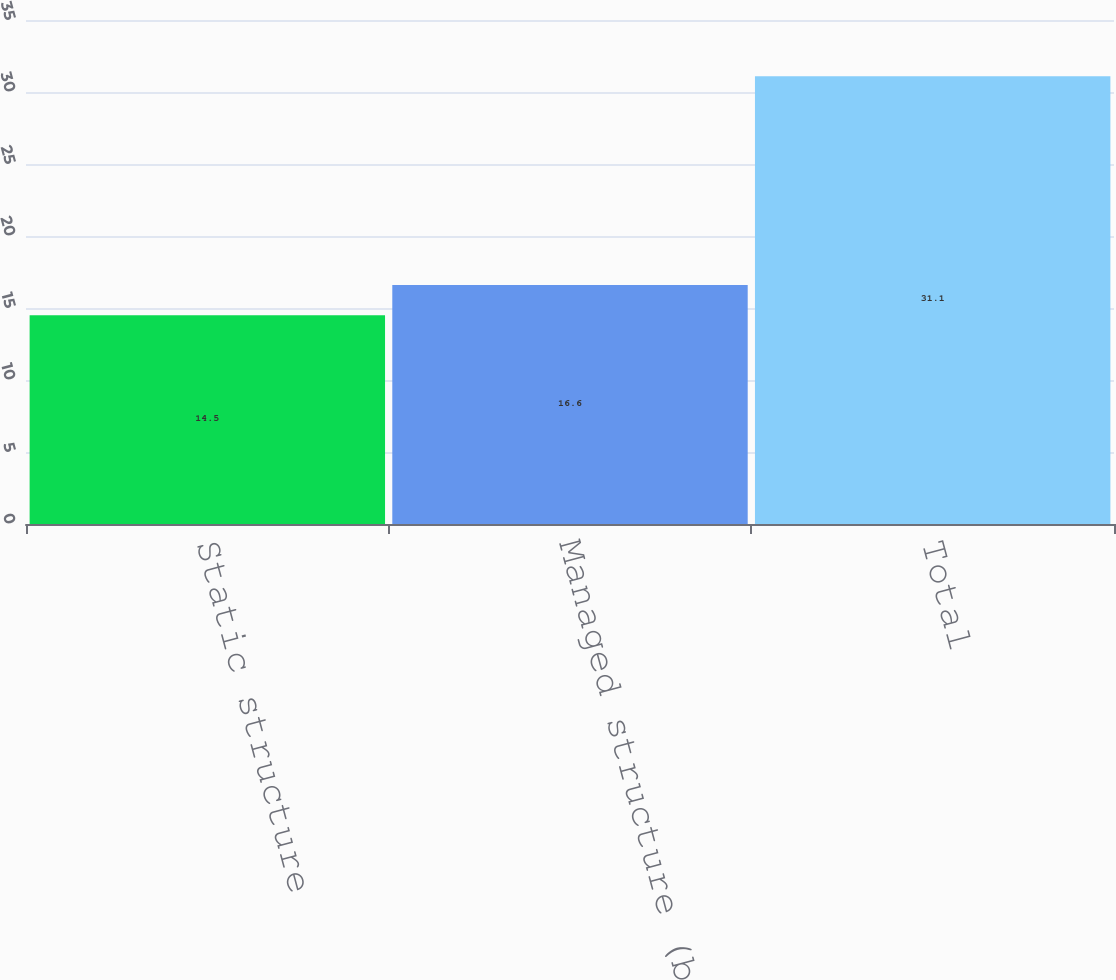<chart> <loc_0><loc_0><loc_500><loc_500><bar_chart><fcel>Static structure<fcel>Managed structure (b)<fcel>Total<nl><fcel>14.5<fcel>16.6<fcel>31.1<nl></chart> 